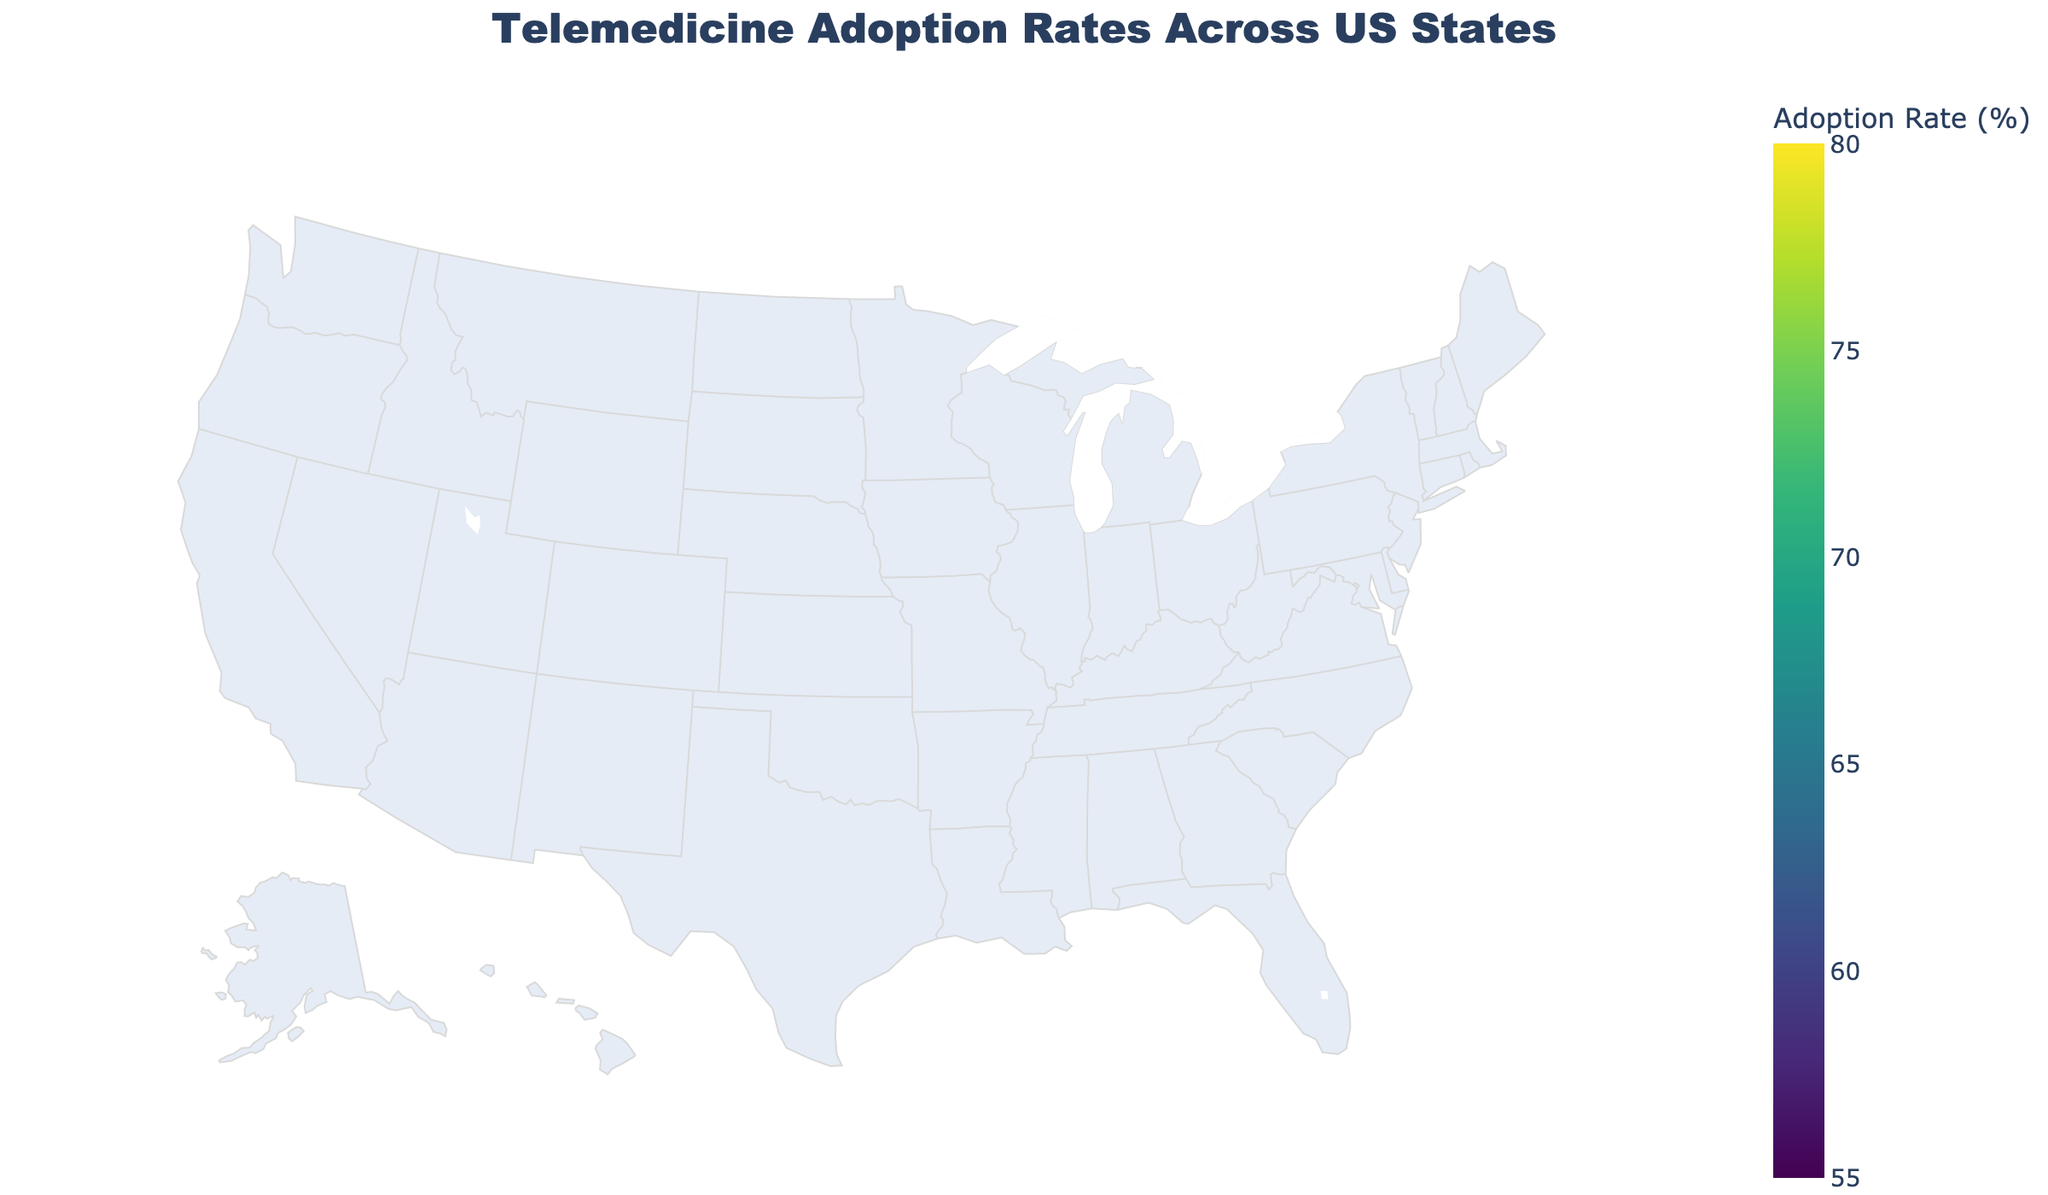What's the title of the figure? The title of a figure is typically located at the top and summarises the content visually represented.
Answer: Telemedicine Adoption Rates Across US States Which state has the highest telemedicine adoption rate? To determine this, look for the state with the darkest color on the Viridis scale, indicating a higher percentage.
Answer: California Which regions are represented in the figure? Examine the labels and custom data provided for each state to identify the different regions.
Answer: West, Northeast, South, Midwest What is the telemedicine adoption rate for Texas? Find Texas on the map and refer to the color legend to determine the corresponding adoption rate.
Answer: 65.9% Compare the adoption rates of Florida and Georgia. Which state has a higher rate? Locate both Florida and Georgia on the map and check their respective colors and values. Compare the numerical values of their adoption rates.
Answer: Florida What is the average telemedicine adoption rate for the Midwest region? Identify the states in the Midwest (Illinois, Ohio, Michigan, Minnesota, Wisconsin, Missouri), sum their adoption rates, and divide by the number of states: (61.8 + 59.4 + 60.7 + 67.2 + 58.9 + 57.8) / 6 = 365.8 / 6.
Answer: 60.97% List states in the West region with an adoption rate above 70%. Check each state in the West against the adoption rate threshold and list those that meet or exceed it (California, Washington, Colorado, Oregon).
Answer: California, Washington, Colorado, Oregon Which state in the South region has the lowest telemedicine adoption rate? Identify all Southern states on the map, compare their adoption rates, and find the lowest one.
Answer: Tennessee What is the range of telemedicine adoption rates represented in the figure? The scale on the map ranges from the lowest to the highest values shown. Look at the color bar for the limits.
Answer: 57.8% to 78.5% Does the Midwest region generally have higher or lower adoption rates compared to the West region? Compare the adoption rates of states in the Midwest with those in the West to determine the general trend. States in the West generally have higher adoption rates.
Answer: Lower 